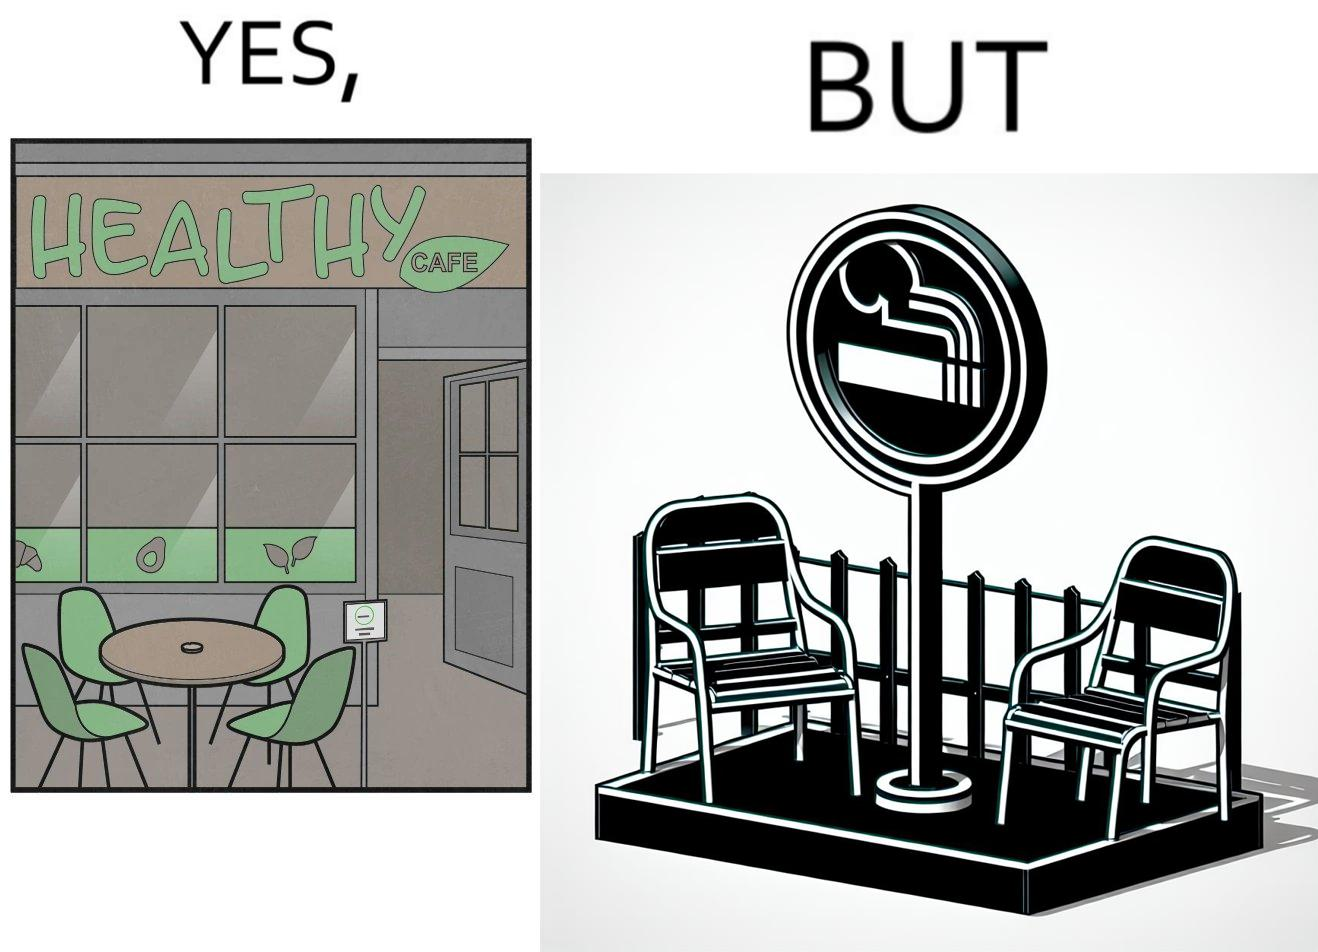Would you classify this image as satirical? Yes, this image is satirical. 